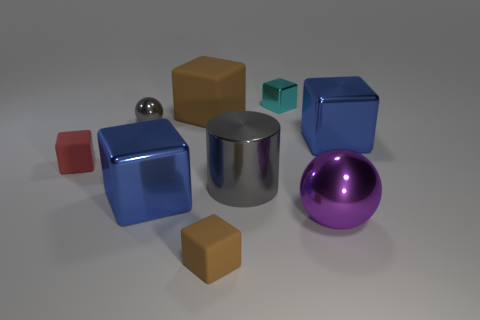Does the brown block that is in front of the purple thing have the same size as the gray object that is left of the large gray thing?
Provide a succinct answer. Yes. The metallic thing on the right side of the big purple object on the right side of the small thing in front of the small red thing is what color?
Provide a succinct answer. Blue. Is there a blue object of the same shape as the big brown rubber thing?
Provide a short and direct response. Yes. Is the number of small shiny objects that are to the left of the large gray cylinder the same as the number of things to the left of the small metallic sphere?
Offer a very short reply. Yes. Does the blue metallic object that is in front of the large gray object have the same shape as the big gray object?
Your response must be concise. No. Is the tiny red matte thing the same shape as the small brown object?
Offer a very short reply. Yes. How many shiny things are either big purple objects or large blue objects?
Your response must be concise. 3. There is another thing that is the same color as the large rubber thing; what material is it?
Your response must be concise. Rubber. Do the purple metal thing and the red rubber object have the same size?
Give a very brief answer. No. What number of objects are large red matte objects or blue blocks that are behind the large cylinder?
Your response must be concise. 1. 